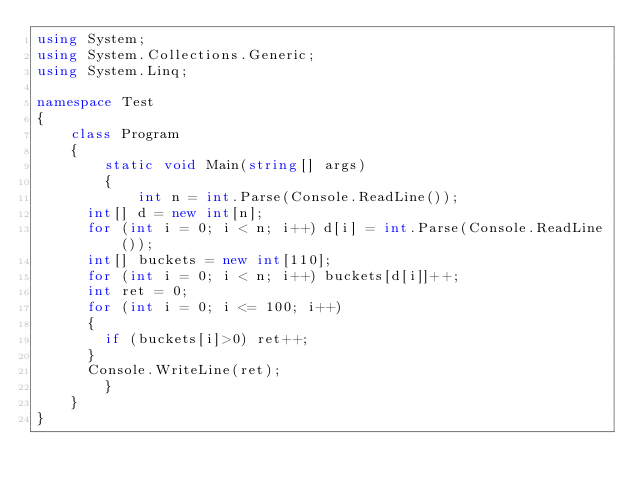Convert code to text. <code><loc_0><loc_0><loc_500><loc_500><_C#_>using System;
using System.Collections.Generic;
using System.Linq;

namespace Test
{
    class Program
    {
        static void Main(string[] args)
        {
            int n = int.Parse(Console.ReadLine());
			int[] d = new int[n];
			for (int i = 0; i < n; i++) d[i] = int.Parse(Console.ReadLine());
			int[] buckets = new int[110];
			for (int i = 0; i < n; i++) buckets[d[i]]++;
			int ret = 0;
			for (int i = 0; i <= 100; i++)
			{
				if (buckets[i]>0) ret++;
			}
			Console.WriteLine(ret);
        }
    }
}
</code> 